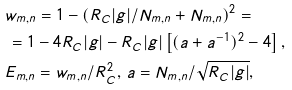Convert formula to latex. <formula><loc_0><loc_0><loc_500><loc_500>& w _ { m , n } = 1 - ( R _ { C } | g | / N _ { m , n } + N _ { m , n } ) ^ { 2 } = \\ & \, = 1 - 4 R _ { C } | g | - R _ { C } | g | \left [ ( a + a ^ { - 1 } ) ^ { 2 } - 4 \right ] , \\ & E _ { m , n } = w _ { m , n } / R _ { C } ^ { 2 } , \, a = N _ { m , n } / \sqrt { R _ { C } | g | } ,</formula> 